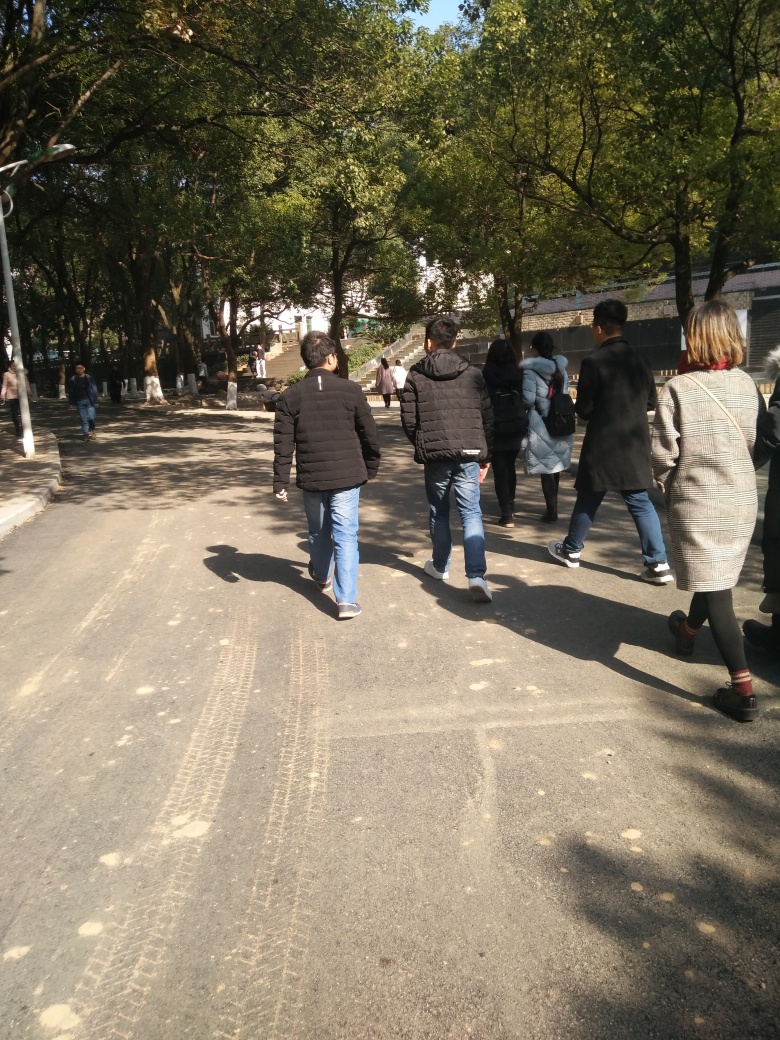Is the background relatively clear? The background of the image features a variety of trees with light and dark green foliage under a clear sky. The clarity of the background is sufficient to discern individual trees and their branches, but there are some shadows being cast on the ground that may slightly obscure the finer details. 